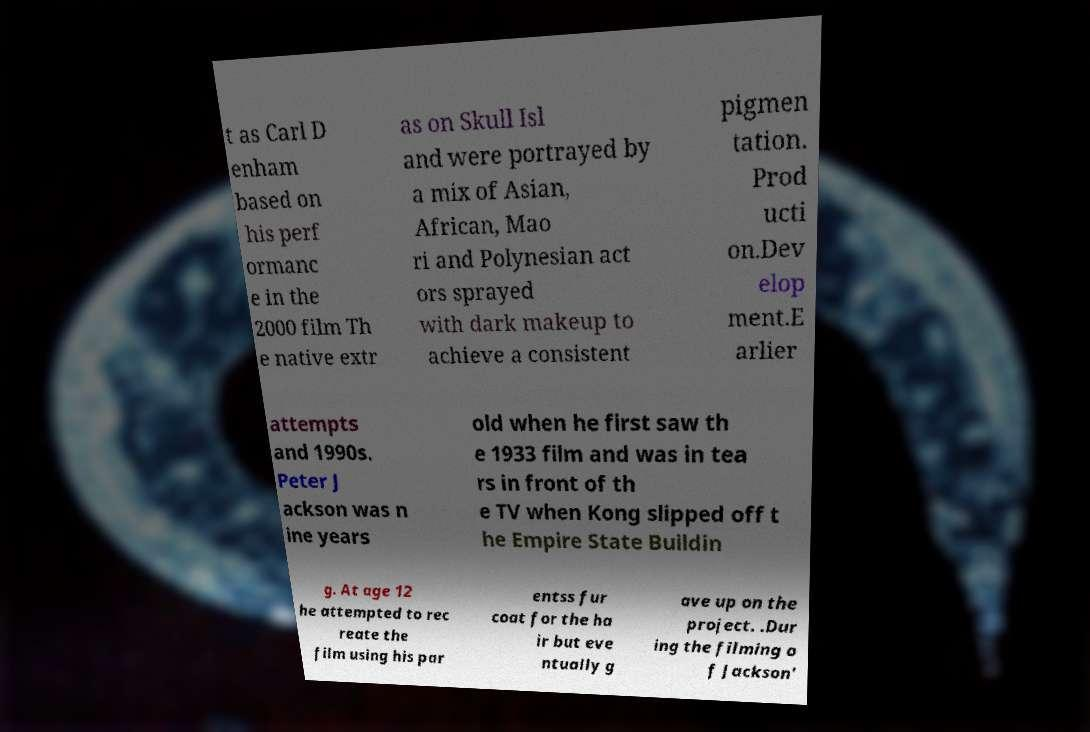Please identify and transcribe the text found in this image. t as Carl D enham based on his perf ormanc e in the 2000 film Th e native extr as on Skull Isl and were portrayed by a mix of Asian, African, Mao ri and Polynesian act ors sprayed with dark makeup to achieve a consistent pigmen tation. Prod ucti on.Dev elop ment.E arlier attempts and 1990s. Peter J ackson was n ine years old when he first saw th e 1933 film and was in tea rs in front of th e TV when Kong slipped off t he Empire State Buildin g. At age 12 he attempted to rec reate the film using his par entss fur coat for the ha ir but eve ntually g ave up on the project. .Dur ing the filming o f Jackson' 